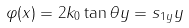<formula> <loc_0><loc_0><loc_500><loc_500>\varphi ( x ) = 2 k _ { 0 } \tan \theta y = s _ { 1 y } y</formula> 